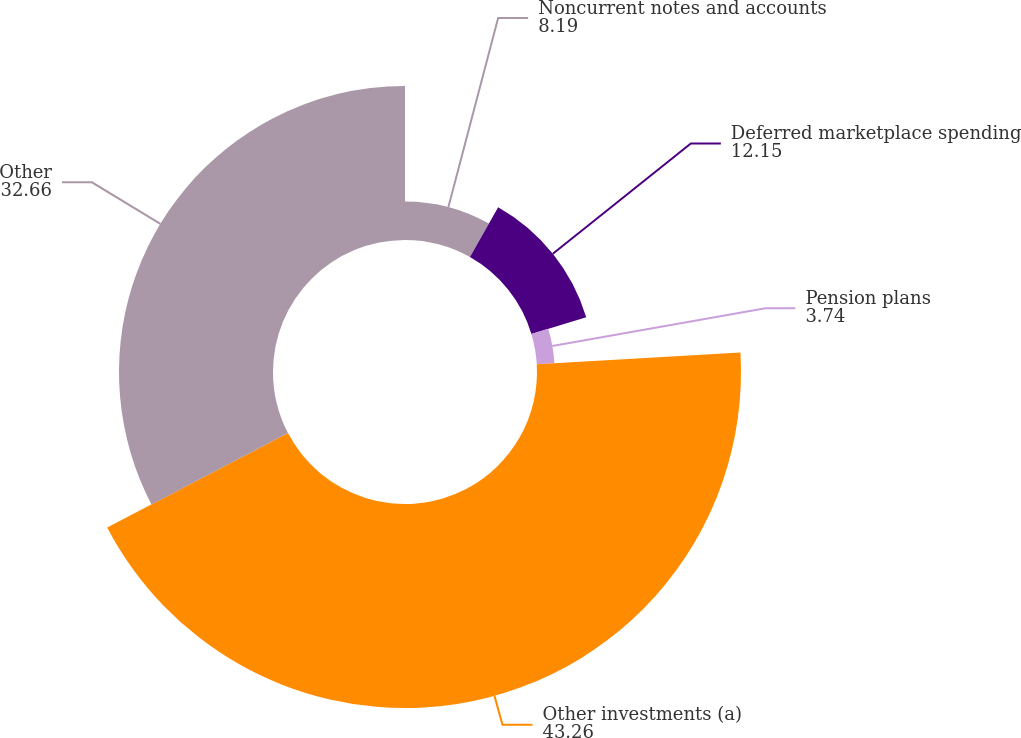Convert chart to OTSL. <chart><loc_0><loc_0><loc_500><loc_500><pie_chart><fcel>Noncurrent notes and accounts<fcel>Deferred marketplace spending<fcel>Pension plans<fcel>Other investments (a)<fcel>Other<nl><fcel>8.19%<fcel>12.15%<fcel>3.74%<fcel>43.26%<fcel>32.66%<nl></chart> 